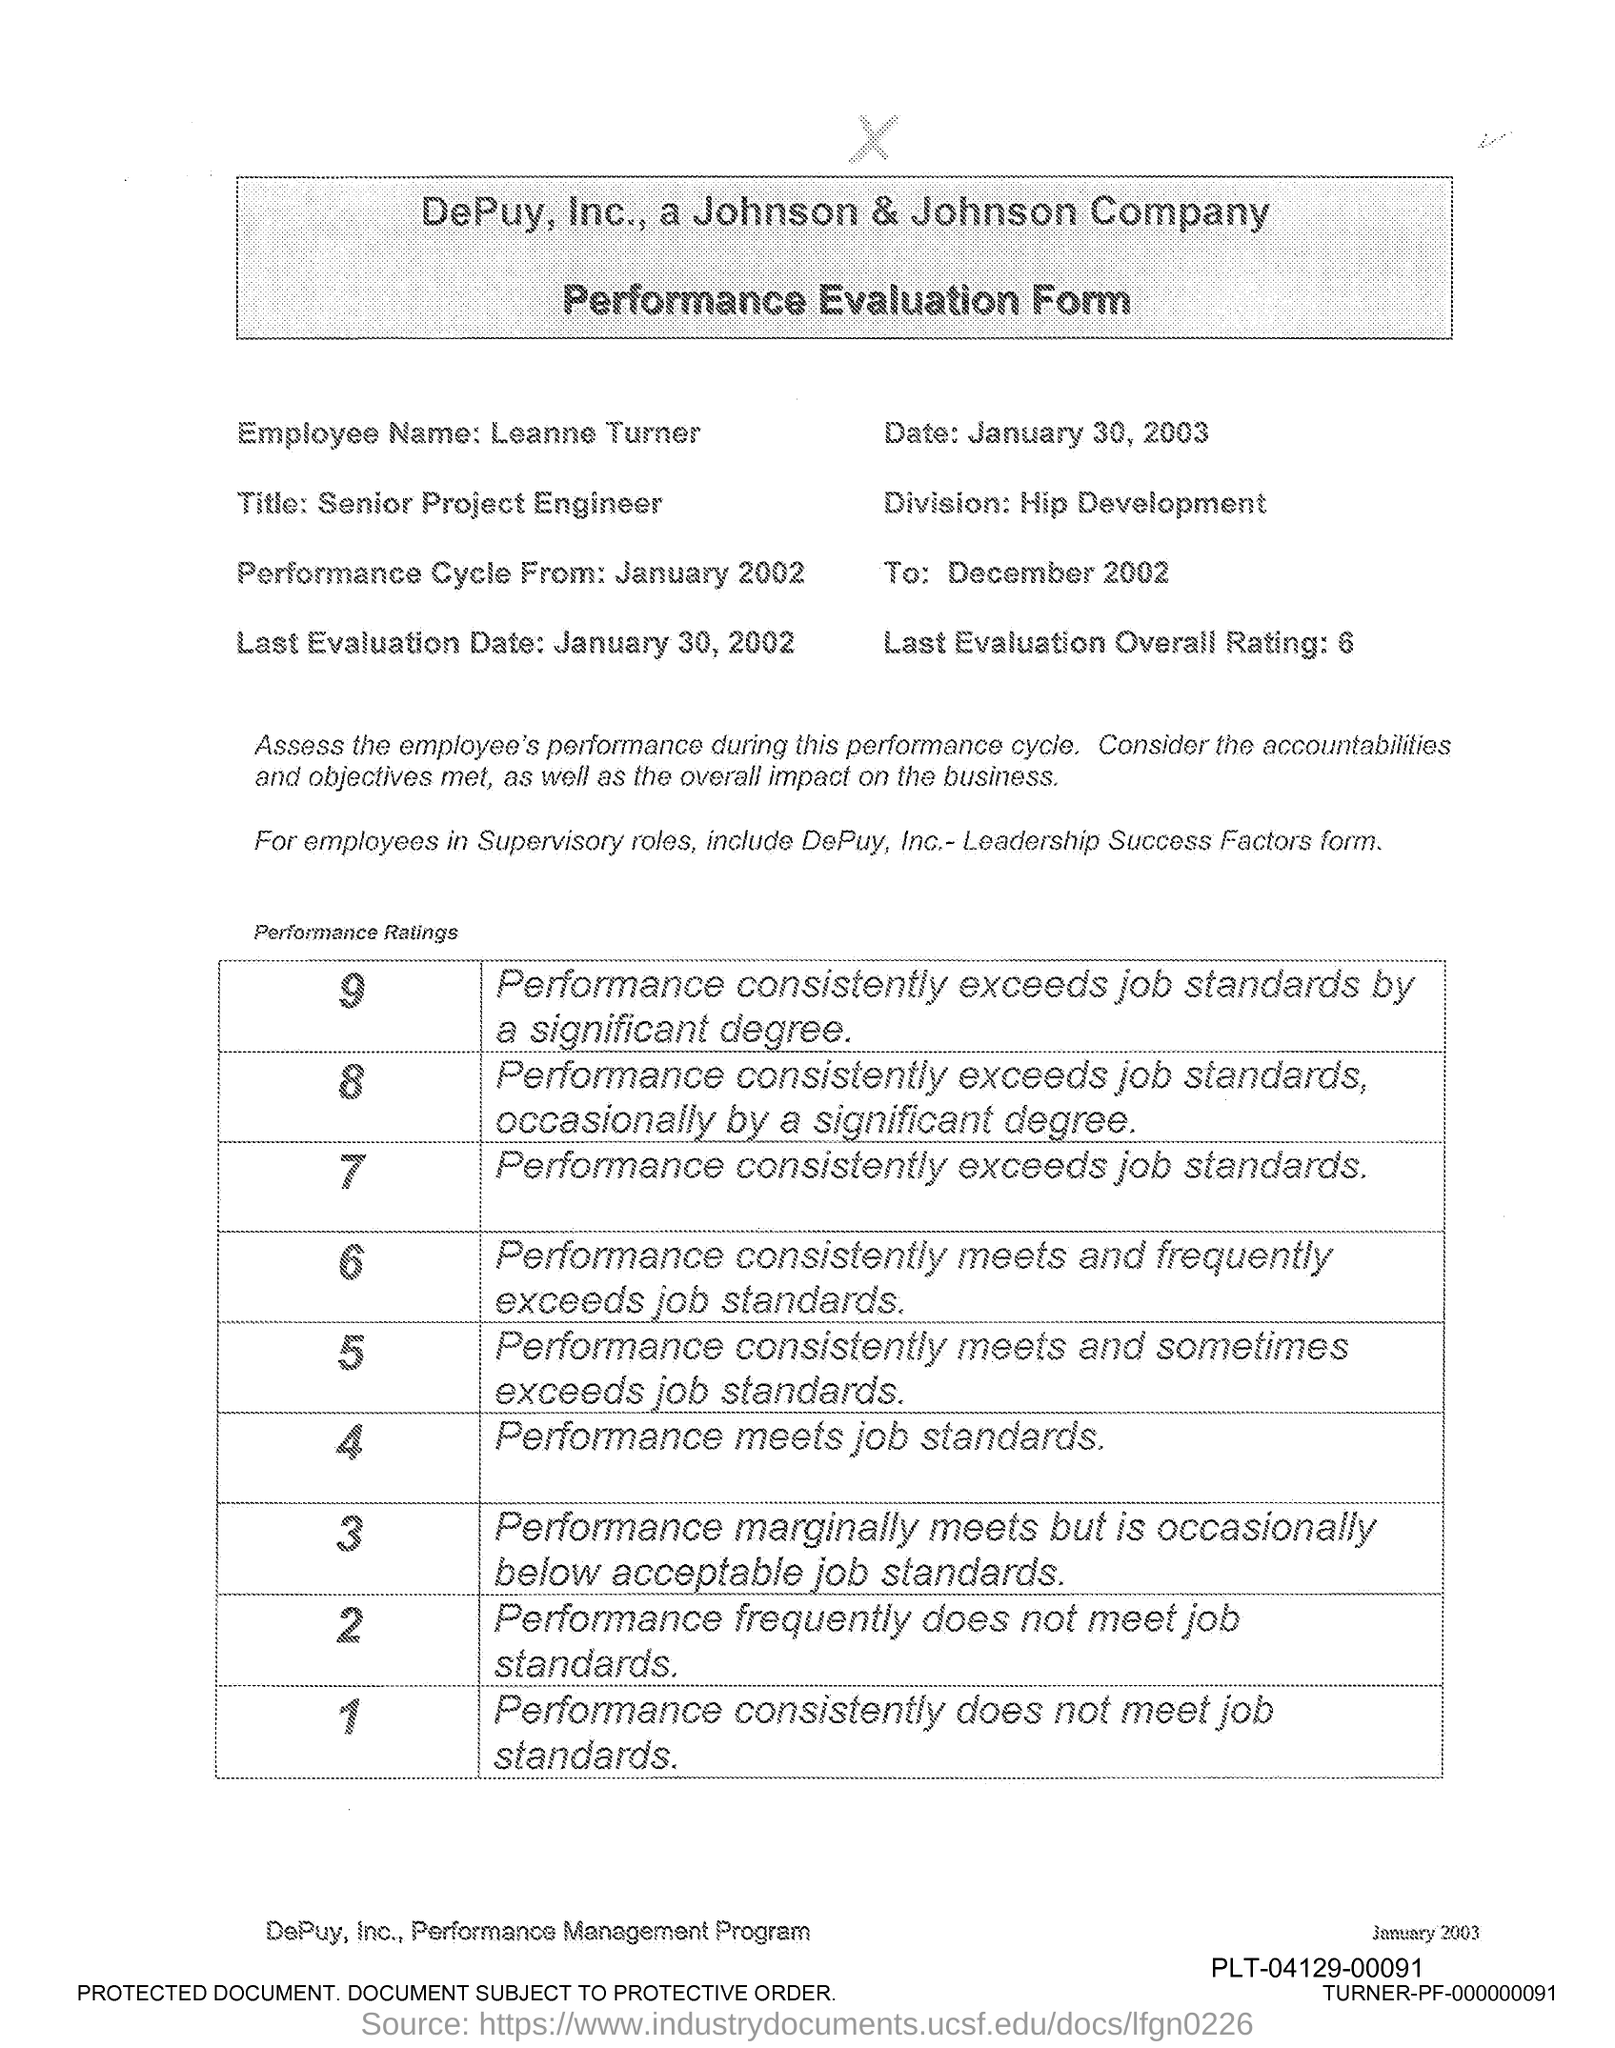Outline some significant characteristics in this image. The last overall rating mentioned in the form is 6. The employee name provided in the form is 'Leanne Turner'. The performance evaluation form was issued on January 30, 2003. Leanne Turner works in the Hip Development division. The performance cycle begins in January 2002, as stated on the evaluation form. 